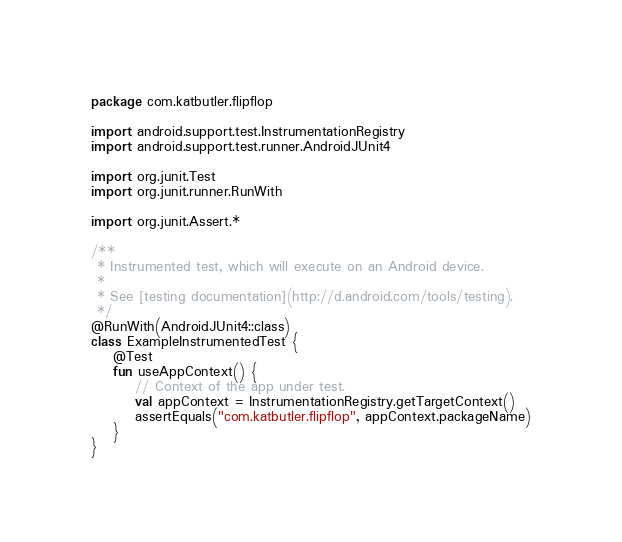Convert code to text. <code><loc_0><loc_0><loc_500><loc_500><_Kotlin_>package com.katbutler.flipflop

import android.support.test.InstrumentationRegistry
import android.support.test.runner.AndroidJUnit4

import org.junit.Test
import org.junit.runner.RunWith

import org.junit.Assert.*

/**
 * Instrumented test, which will execute on an Android device.
 *
 * See [testing documentation](http://d.android.com/tools/testing).
 */
@RunWith(AndroidJUnit4::class)
class ExampleInstrumentedTest {
    @Test
    fun useAppContext() {
        // Context of the app under test.
        val appContext = InstrumentationRegistry.getTargetContext()
        assertEquals("com.katbutler.flipflop", appContext.packageName)
    }
}
</code> 